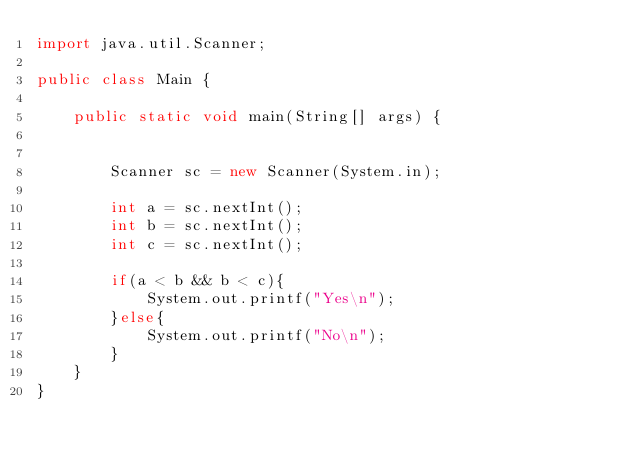<code> <loc_0><loc_0><loc_500><loc_500><_Java_>import java.util.Scanner;
 
public class Main {
 
    public static void main(String[] args) {
 
 
        Scanner sc = new Scanner(System.in);
 
        int a = sc.nextInt();
        int b = sc.nextInt();
        int c = sc.nextInt();
 
        if(a < b && b < c){
            System.out.printf("Yes\n");
        }else{
            System.out.printf("No\n");
        }
    }
}
</code> 